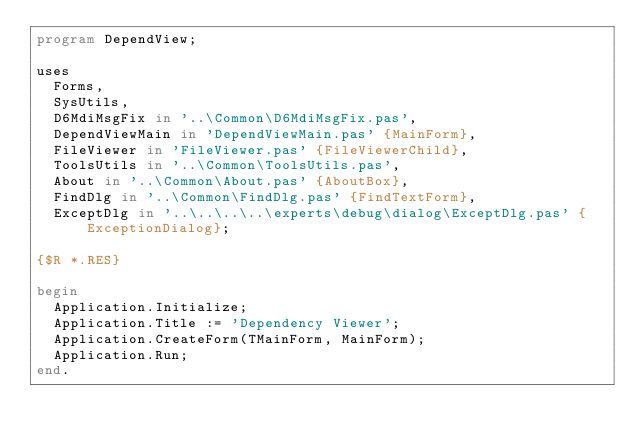Convert code to text. <code><loc_0><loc_0><loc_500><loc_500><_Pascal_>program DependView;

uses
  Forms,
  SysUtils,
  D6MdiMsgFix in '..\Common\D6MdiMsgFix.pas',
  DependViewMain in 'DependViewMain.pas' {MainForm},
  FileViewer in 'FileViewer.pas' {FileViewerChild},
  ToolsUtils in '..\Common\ToolsUtils.pas',
  About in '..\Common\About.pas' {AboutBox},
  FindDlg in '..\Common\FindDlg.pas' {FindTextForm},
  ExceptDlg in '..\..\..\..\experts\debug\dialog\ExceptDlg.pas' {ExceptionDialog};

{$R *.RES}

begin
  Application.Initialize;
  Application.Title := 'Dependency Viewer';
  Application.CreateForm(TMainForm, MainForm);
  Application.Run;
end.
</code> 